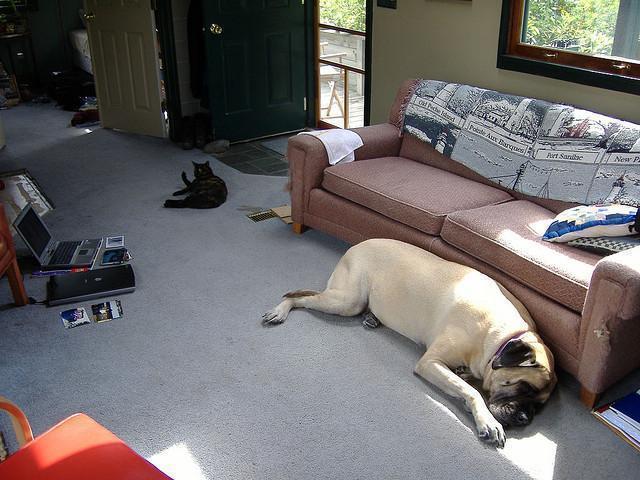Where is the person most likely working in the living room while the pets lounge?
Make your selection from the four choices given to correctly answer the question.
Options: Floor, sofa, desk, table. Floor. 